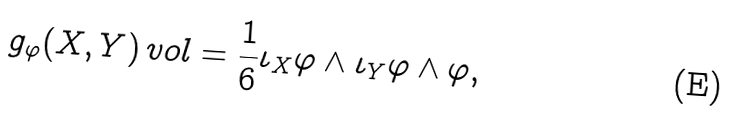<formula> <loc_0><loc_0><loc_500><loc_500>g _ { \varphi } ( X , Y ) \, v o l = \frac { 1 } { 6 } \iota _ { X } \varphi \wedge \iota _ { Y } \varphi \wedge \varphi ,</formula> 